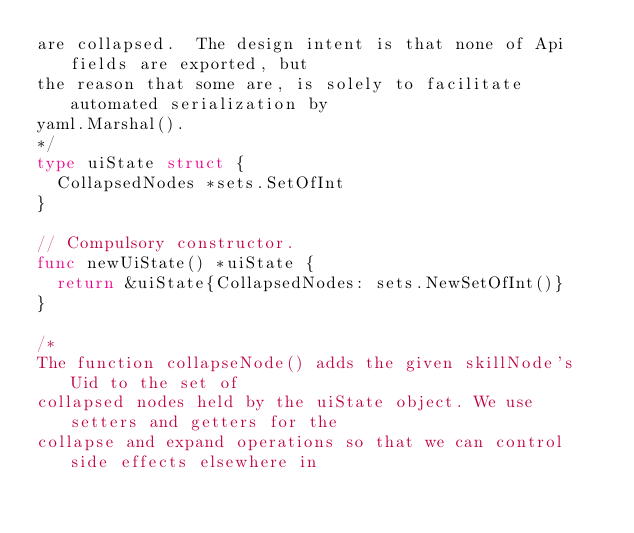Convert code to text. <code><loc_0><loc_0><loc_500><loc_500><_Go_>are collapsed.  The design intent is that none of Api fields are exported, but
the reason that some are, is solely to facilitate automated serialization by
yaml.Marshal().
*/
type uiState struct {
	CollapsedNodes *sets.SetOfInt
}

// Compulsory constructor.
func newUiState() *uiState {
	return &uiState{CollapsedNodes: sets.NewSetOfInt()}
}

/*
The function collapseNode() adds the given skillNode's Uid to the set of
collapsed nodes held by the uiState object. We use setters and getters for the
collapse and expand operations so that we can control side effects elsewhere in</code> 